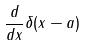Convert formula to latex. <formula><loc_0><loc_0><loc_500><loc_500>\frac { d } { d x } \delta ( x - a )</formula> 